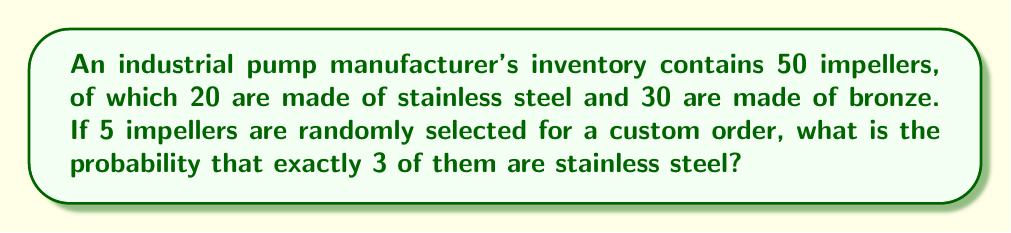Teach me how to tackle this problem. Let's approach this step-by-step using the concept of hypergeometric distribution:

1) We are selecting 5 impellers out of 50, without replacement.

2) We want exactly 3 stainless steel impellers out of the 20 available.

3) The remaining 2 impellers must be bronze, out of the 30 available.

4) The probability is calculated using the formula:

   $$P(X=k) = \frac{\binom{K}{k} \binom{N-K}{n-k}}{\binom{N}{n}}$$

   Where:
   $N$ = total number of items (50 impellers)
   $K$ = number of items with the desired characteristic (20 stainless steel impellers)
   $n$ = number of items drawn (5 impellers)
   $k$ = number of items with the desired characteristic in the draw (3 stainless steel impellers)

5) Substituting our values:

   $$P(X=3) = \frac{\binom{20}{3} \binom{50-20}{5-3}}{\binom{50}{5}}$$

6) Calculating each combination:
   
   $\binom{20}{3} = 1140$
   $\binom{30}{2} = 435$
   $\binom{50}{5} = 2118760$

7) Substituting these values:

   $$P(X=3) = \frac{1140 \cdot 435}{2118760} = \frac{495900}{2118760} \approx 0.2340$$
Answer: $\frac{495900}{2118760} \approx 0.2340$ 